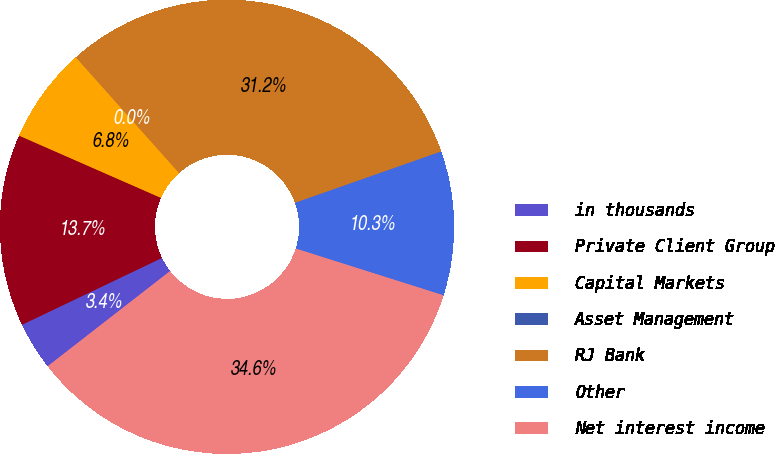Convert chart. <chart><loc_0><loc_0><loc_500><loc_500><pie_chart><fcel>in thousands<fcel>Private Client Group<fcel>Capital Markets<fcel>Asset Management<fcel>RJ Bank<fcel>Other<fcel>Net interest income<nl><fcel>3.43%<fcel>13.67%<fcel>6.84%<fcel>0.01%<fcel>31.19%<fcel>10.26%<fcel>34.6%<nl></chart> 